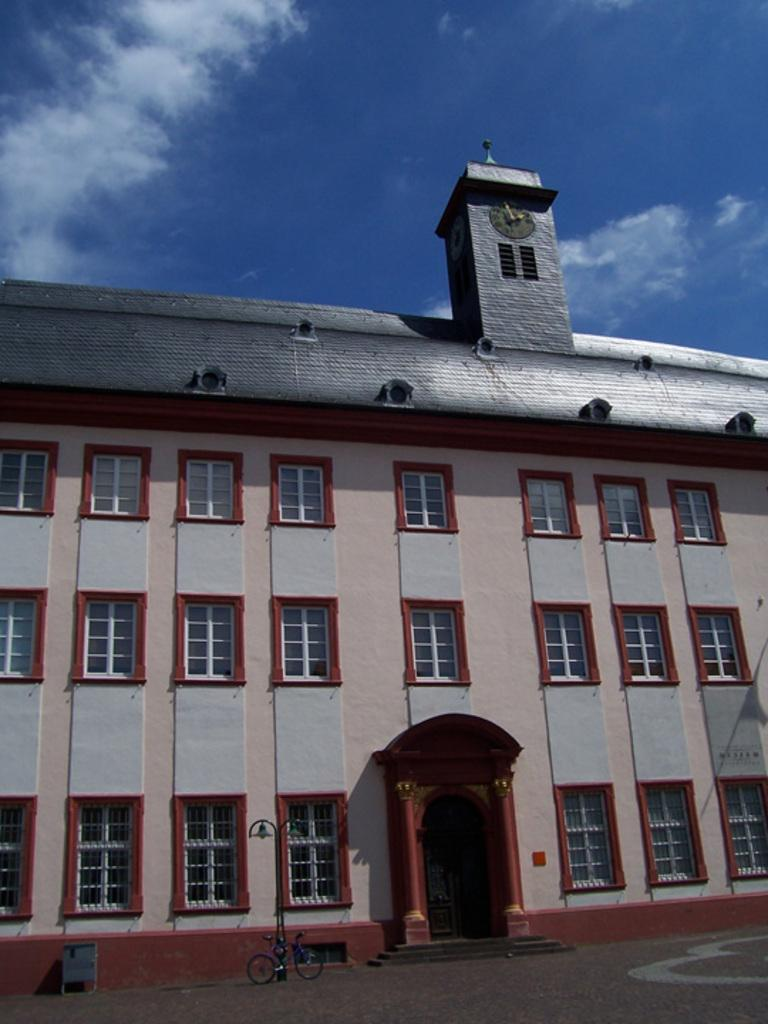What is the main structure in the center of the image? There is a building in the center of the image. What can be seen in front of the building? There is a bicycle and a dustbin in front of the building. What is the weather like in the image? The sky is sunny in the image. Is there any time-related feature on the building? Yes, there is a clock at the top of the building. Can you see any mountains in the background of the image? There are no mountains visible in the image. How many fingers can be seen on the clock in the image? The clock in the image does not have fingers; it is likely a digital clock or a clock with hands. 